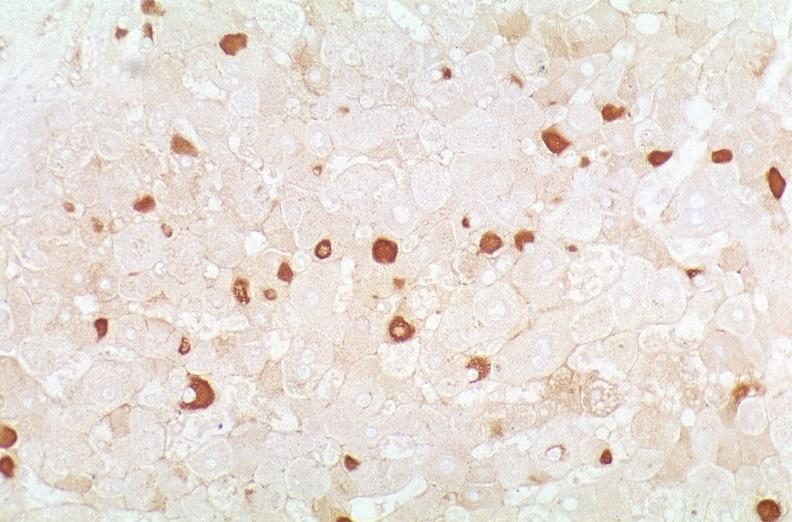s hepatobiliary present?
Answer the question using a single word or phrase. Yes 